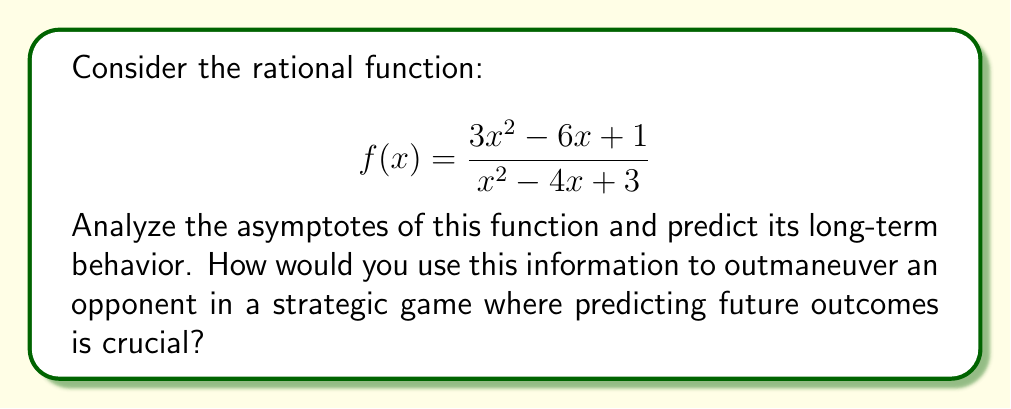What is the answer to this math problem? To analyze the asymptotes and predict long-term behavior, we'll follow these steps:

1) Horizontal asymptote:
   Compare the degrees of the numerator and denominator.
   Both have degree 2, so we divide the leading coefficients:
   $$\lim_{x \to \infty} f(x) = \frac{3}{1} = 3$$
   The horizontal asymptote is y = 3.

2) Vertical asymptotes:
   Find where the denominator equals zero:
   $$x^2 - 4x + 3 = (x-1)(x-3) = 0$$
   $$x = 1 \text{ or } x = 3$$
   Vertical asymptotes occur at x = 1 and x = 3.

3) Holes:
   Check if any factor cancels between numerator and denominator:
   No common factors, so there are no holes.

4) Long-term behavior:
   As x approaches positive or negative infinity, f(x) approaches 3.
   Near x = 1 and x = 3, f(x) grows extremely large (positive or negative).

5) Strategic application:
   In a game, this behavior could represent a system that stabilizes over time (approaching 3) but has critical points (at 1 and 3) where outcomes become extreme. A defensive player could use this knowledge to avoid these critical points and play for the long-term stable outcome.
Answer: Horizontal asymptote: y = 3; Vertical asymptotes: x = 1, x = 3; Long-term behavior: f(x) approaches 3 as x approaches ±∞. 